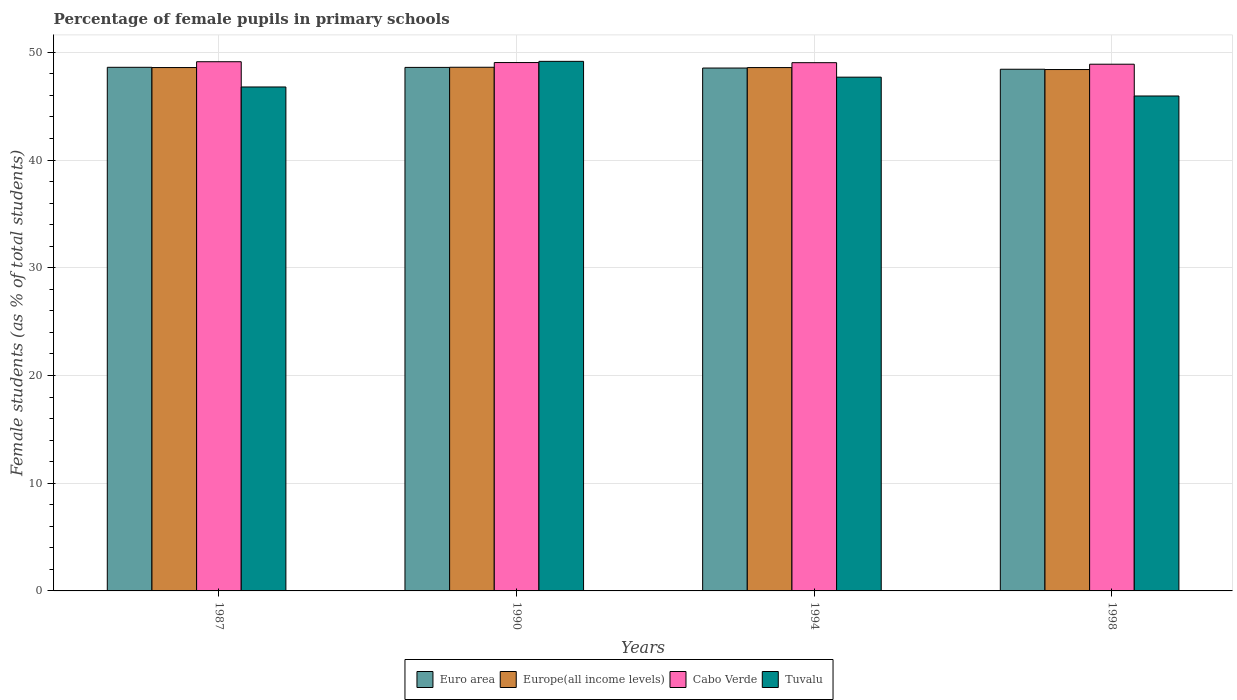How many different coloured bars are there?
Provide a short and direct response. 4. How many groups of bars are there?
Keep it short and to the point. 4. Are the number of bars on each tick of the X-axis equal?
Offer a very short reply. Yes. How many bars are there on the 1st tick from the left?
Offer a very short reply. 4. What is the label of the 2nd group of bars from the left?
Ensure brevity in your answer.  1990. In how many cases, is the number of bars for a given year not equal to the number of legend labels?
Offer a very short reply. 0. What is the percentage of female pupils in primary schools in Euro area in 1987?
Make the answer very short. 48.61. Across all years, what is the maximum percentage of female pupils in primary schools in Euro area?
Provide a short and direct response. 48.61. Across all years, what is the minimum percentage of female pupils in primary schools in Cabo Verde?
Give a very brief answer. 48.9. In which year was the percentage of female pupils in primary schools in Europe(all income levels) maximum?
Offer a terse response. 1990. In which year was the percentage of female pupils in primary schools in Tuvalu minimum?
Ensure brevity in your answer.  1998. What is the total percentage of female pupils in primary schools in Euro area in the graph?
Your answer should be very brief. 194.19. What is the difference between the percentage of female pupils in primary schools in Europe(all income levels) in 1990 and that in 1998?
Provide a short and direct response. 0.21. What is the difference between the percentage of female pupils in primary schools in Europe(all income levels) in 1987 and the percentage of female pupils in primary schools in Cabo Verde in 1994?
Your answer should be very brief. -0.45. What is the average percentage of female pupils in primary schools in Cabo Verde per year?
Offer a very short reply. 49.03. In the year 1987, what is the difference between the percentage of female pupils in primary schools in Europe(all income levels) and percentage of female pupils in primary schools in Tuvalu?
Offer a very short reply. 1.8. What is the ratio of the percentage of female pupils in primary schools in Cabo Verde in 1994 to that in 1998?
Keep it short and to the point. 1. Is the percentage of female pupils in primary schools in Euro area in 1994 less than that in 1998?
Provide a succinct answer. No. What is the difference between the highest and the second highest percentage of female pupils in primary schools in Europe(all income levels)?
Provide a succinct answer. 0.03. What is the difference between the highest and the lowest percentage of female pupils in primary schools in Tuvalu?
Make the answer very short. 3.22. In how many years, is the percentage of female pupils in primary schools in Euro area greater than the average percentage of female pupils in primary schools in Euro area taken over all years?
Offer a terse response. 2. Is the sum of the percentage of female pupils in primary schools in Cabo Verde in 1987 and 1998 greater than the maximum percentage of female pupils in primary schools in Euro area across all years?
Your answer should be compact. Yes. What does the 1st bar from the left in 1994 represents?
Provide a short and direct response. Euro area. How many bars are there?
Make the answer very short. 16. Are the values on the major ticks of Y-axis written in scientific E-notation?
Make the answer very short. No. Does the graph contain any zero values?
Give a very brief answer. No. Does the graph contain grids?
Make the answer very short. Yes. How many legend labels are there?
Offer a very short reply. 4. What is the title of the graph?
Ensure brevity in your answer.  Percentage of female pupils in primary schools. Does "Euro area" appear as one of the legend labels in the graph?
Provide a succinct answer. Yes. What is the label or title of the X-axis?
Your answer should be very brief. Years. What is the label or title of the Y-axis?
Offer a very short reply. Female students (as % of total students). What is the Female students (as % of total students) in Euro area in 1987?
Make the answer very short. 48.61. What is the Female students (as % of total students) in Europe(all income levels) in 1987?
Ensure brevity in your answer.  48.59. What is the Female students (as % of total students) in Cabo Verde in 1987?
Your answer should be compact. 49.13. What is the Female students (as % of total students) of Tuvalu in 1987?
Ensure brevity in your answer.  46.78. What is the Female students (as % of total students) in Euro area in 1990?
Offer a very short reply. 48.6. What is the Female students (as % of total students) in Europe(all income levels) in 1990?
Make the answer very short. 48.62. What is the Female students (as % of total students) of Cabo Verde in 1990?
Provide a succinct answer. 49.05. What is the Female students (as % of total students) in Tuvalu in 1990?
Give a very brief answer. 49.16. What is the Female students (as % of total students) of Euro area in 1994?
Provide a succinct answer. 48.54. What is the Female students (as % of total students) in Europe(all income levels) in 1994?
Your answer should be compact. 48.59. What is the Female students (as % of total students) of Cabo Verde in 1994?
Your answer should be compact. 49.04. What is the Female students (as % of total students) of Tuvalu in 1994?
Give a very brief answer. 47.7. What is the Female students (as % of total students) in Euro area in 1998?
Ensure brevity in your answer.  48.43. What is the Female students (as % of total students) in Europe(all income levels) in 1998?
Your response must be concise. 48.4. What is the Female students (as % of total students) in Cabo Verde in 1998?
Give a very brief answer. 48.9. What is the Female students (as % of total students) in Tuvalu in 1998?
Give a very brief answer. 45.95. Across all years, what is the maximum Female students (as % of total students) of Euro area?
Give a very brief answer. 48.61. Across all years, what is the maximum Female students (as % of total students) of Europe(all income levels)?
Offer a terse response. 48.62. Across all years, what is the maximum Female students (as % of total students) of Cabo Verde?
Offer a very short reply. 49.13. Across all years, what is the maximum Female students (as % of total students) of Tuvalu?
Offer a very short reply. 49.16. Across all years, what is the minimum Female students (as % of total students) of Euro area?
Keep it short and to the point. 48.43. Across all years, what is the minimum Female students (as % of total students) of Europe(all income levels)?
Keep it short and to the point. 48.4. Across all years, what is the minimum Female students (as % of total students) in Cabo Verde?
Make the answer very short. 48.9. Across all years, what is the minimum Female students (as % of total students) in Tuvalu?
Offer a very short reply. 45.95. What is the total Female students (as % of total students) in Euro area in the graph?
Your answer should be compact. 194.19. What is the total Female students (as % of total students) in Europe(all income levels) in the graph?
Give a very brief answer. 194.19. What is the total Female students (as % of total students) of Cabo Verde in the graph?
Offer a terse response. 196.12. What is the total Female students (as % of total students) in Tuvalu in the graph?
Offer a terse response. 189.59. What is the difference between the Female students (as % of total students) in Euro area in 1987 and that in 1990?
Your response must be concise. 0.01. What is the difference between the Female students (as % of total students) of Europe(all income levels) in 1987 and that in 1990?
Provide a short and direct response. -0.03. What is the difference between the Female students (as % of total students) of Cabo Verde in 1987 and that in 1990?
Provide a short and direct response. 0.08. What is the difference between the Female students (as % of total students) in Tuvalu in 1987 and that in 1990?
Offer a terse response. -2.38. What is the difference between the Female students (as % of total students) of Euro area in 1987 and that in 1994?
Your answer should be very brief. 0.07. What is the difference between the Female students (as % of total students) of Europe(all income levels) in 1987 and that in 1994?
Ensure brevity in your answer.  0. What is the difference between the Female students (as % of total students) of Cabo Verde in 1987 and that in 1994?
Your answer should be very brief. 0.09. What is the difference between the Female students (as % of total students) in Tuvalu in 1987 and that in 1994?
Your response must be concise. -0.91. What is the difference between the Female students (as % of total students) of Euro area in 1987 and that in 1998?
Your answer should be very brief. 0.18. What is the difference between the Female students (as % of total students) of Europe(all income levels) in 1987 and that in 1998?
Offer a very short reply. 0.18. What is the difference between the Female students (as % of total students) in Cabo Verde in 1987 and that in 1998?
Offer a terse response. 0.23. What is the difference between the Female students (as % of total students) of Tuvalu in 1987 and that in 1998?
Provide a short and direct response. 0.84. What is the difference between the Female students (as % of total students) of Euro area in 1990 and that in 1994?
Your response must be concise. 0.06. What is the difference between the Female students (as % of total students) of Europe(all income levels) in 1990 and that in 1994?
Offer a terse response. 0.03. What is the difference between the Female students (as % of total students) in Cabo Verde in 1990 and that in 1994?
Keep it short and to the point. 0.01. What is the difference between the Female students (as % of total students) in Tuvalu in 1990 and that in 1994?
Your answer should be compact. 1.47. What is the difference between the Female students (as % of total students) of Euro area in 1990 and that in 1998?
Make the answer very short. 0.17. What is the difference between the Female students (as % of total students) in Europe(all income levels) in 1990 and that in 1998?
Offer a terse response. 0.21. What is the difference between the Female students (as % of total students) in Cabo Verde in 1990 and that in 1998?
Ensure brevity in your answer.  0.15. What is the difference between the Female students (as % of total students) of Tuvalu in 1990 and that in 1998?
Provide a short and direct response. 3.22. What is the difference between the Female students (as % of total students) of Euro area in 1994 and that in 1998?
Make the answer very short. 0.11. What is the difference between the Female students (as % of total students) of Europe(all income levels) in 1994 and that in 1998?
Your answer should be compact. 0.18. What is the difference between the Female students (as % of total students) of Cabo Verde in 1994 and that in 1998?
Offer a very short reply. 0.14. What is the difference between the Female students (as % of total students) of Tuvalu in 1994 and that in 1998?
Keep it short and to the point. 1.75. What is the difference between the Female students (as % of total students) in Euro area in 1987 and the Female students (as % of total students) in Europe(all income levels) in 1990?
Offer a very short reply. -0.01. What is the difference between the Female students (as % of total students) of Euro area in 1987 and the Female students (as % of total students) of Cabo Verde in 1990?
Your response must be concise. -0.44. What is the difference between the Female students (as % of total students) in Euro area in 1987 and the Female students (as % of total students) in Tuvalu in 1990?
Provide a succinct answer. -0.55. What is the difference between the Female students (as % of total students) of Europe(all income levels) in 1987 and the Female students (as % of total students) of Cabo Verde in 1990?
Your response must be concise. -0.46. What is the difference between the Female students (as % of total students) of Europe(all income levels) in 1987 and the Female students (as % of total students) of Tuvalu in 1990?
Your answer should be compact. -0.58. What is the difference between the Female students (as % of total students) in Cabo Verde in 1987 and the Female students (as % of total students) in Tuvalu in 1990?
Offer a terse response. -0.04. What is the difference between the Female students (as % of total students) of Euro area in 1987 and the Female students (as % of total students) of Europe(all income levels) in 1994?
Keep it short and to the point. 0.02. What is the difference between the Female students (as % of total students) in Euro area in 1987 and the Female students (as % of total students) in Cabo Verde in 1994?
Give a very brief answer. -0.43. What is the difference between the Female students (as % of total students) in Euro area in 1987 and the Female students (as % of total students) in Tuvalu in 1994?
Your answer should be very brief. 0.91. What is the difference between the Female students (as % of total students) of Europe(all income levels) in 1987 and the Female students (as % of total students) of Cabo Verde in 1994?
Provide a short and direct response. -0.45. What is the difference between the Female students (as % of total students) in Europe(all income levels) in 1987 and the Female students (as % of total students) in Tuvalu in 1994?
Keep it short and to the point. 0.89. What is the difference between the Female students (as % of total students) in Cabo Verde in 1987 and the Female students (as % of total students) in Tuvalu in 1994?
Provide a short and direct response. 1.43. What is the difference between the Female students (as % of total students) in Euro area in 1987 and the Female students (as % of total students) in Europe(all income levels) in 1998?
Keep it short and to the point. 0.21. What is the difference between the Female students (as % of total students) in Euro area in 1987 and the Female students (as % of total students) in Cabo Verde in 1998?
Keep it short and to the point. -0.29. What is the difference between the Female students (as % of total students) of Euro area in 1987 and the Female students (as % of total students) of Tuvalu in 1998?
Your answer should be compact. 2.66. What is the difference between the Female students (as % of total students) in Europe(all income levels) in 1987 and the Female students (as % of total students) in Cabo Verde in 1998?
Keep it short and to the point. -0.31. What is the difference between the Female students (as % of total students) of Europe(all income levels) in 1987 and the Female students (as % of total students) of Tuvalu in 1998?
Offer a terse response. 2.64. What is the difference between the Female students (as % of total students) of Cabo Verde in 1987 and the Female students (as % of total students) of Tuvalu in 1998?
Provide a short and direct response. 3.18. What is the difference between the Female students (as % of total students) in Euro area in 1990 and the Female students (as % of total students) in Europe(all income levels) in 1994?
Your response must be concise. 0.02. What is the difference between the Female students (as % of total students) in Euro area in 1990 and the Female students (as % of total students) in Cabo Verde in 1994?
Your answer should be very brief. -0.44. What is the difference between the Female students (as % of total students) of Euro area in 1990 and the Female students (as % of total students) of Tuvalu in 1994?
Offer a terse response. 0.91. What is the difference between the Female students (as % of total students) of Europe(all income levels) in 1990 and the Female students (as % of total students) of Cabo Verde in 1994?
Give a very brief answer. -0.42. What is the difference between the Female students (as % of total students) of Europe(all income levels) in 1990 and the Female students (as % of total students) of Tuvalu in 1994?
Your answer should be compact. 0.92. What is the difference between the Female students (as % of total students) of Cabo Verde in 1990 and the Female students (as % of total students) of Tuvalu in 1994?
Your response must be concise. 1.36. What is the difference between the Female students (as % of total students) in Euro area in 1990 and the Female students (as % of total students) in Europe(all income levels) in 1998?
Provide a short and direct response. 0.2. What is the difference between the Female students (as % of total students) in Euro area in 1990 and the Female students (as % of total students) in Cabo Verde in 1998?
Provide a succinct answer. -0.3. What is the difference between the Female students (as % of total students) in Euro area in 1990 and the Female students (as % of total students) in Tuvalu in 1998?
Your answer should be compact. 2.65. What is the difference between the Female students (as % of total students) of Europe(all income levels) in 1990 and the Female students (as % of total students) of Cabo Verde in 1998?
Give a very brief answer. -0.28. What is the difference between the Female students (as % of total students) in Europe(all income levels) in 1990 and the Female students (as % of total students) in Tuvalu in 1998?
Make the answer very short. 2.67. What is the difference between the Female students (as % of total students) in Cabo Verde in 1990 and the Female students (as % of total students) in Tuvalu in 1998?
Offer a very short reply. 3.1. What is the difference between the Female students (as % of total students) in Euro area in 1994 and the Female students (as % of total students) in Europe(all income levels) in 1998?
Your response must be concise. 0.14. What is the difference between the Female students (as % of total students) of Euro area in 1994 and the Female students (as % of total students) of Cabo Verde in 1998?
Your response must be concise. -0.35. What is the difference between the Female students (as % of total students) in Euro area in 1994 and the Female students (as % of total students) in Tuvalu in 1998?
Keep it short and to the point. 2.6. What is the difference between the Female students (as % of total students) of Europe(all income levels) in 1994 and the Female students (as % of total students) of Cabo Verde in 1998?
Keep it short and to the point. -0.31. What is the difference between the Female students (as % of total students) of Europe(all income levels) in 1994 and the Female students (as % of total students) of Tuvalu in 1998?
Give a very brief answer. 2.64. What is the difference between the Female students (as % of total students) in Cabo Verde in 1994 and the Female students (as % of total students) in Tuvalu in 1998?
Provide a succinct answer. 3.09. What is the average Female students (as % of total students) of Euro area per year?
Keep it short and to the point. 48.55. What is the average Female students (as % of total students) of Europe(all income levels) per year?
Your response must be concise. 48.55. What is the average Female students (as % of total students) of Cabo Verde per year?
Your answer should be compact. 49.03. What is the average Female students (as % of total students) of Tuvalu per year?
Provide a succinct answer. 47.4. In the year 1987, what is the difference between the Female students (as % of total students) in Euro area and Female students (as % of total students) in Europe(all income levels)?
Offer a very short reply. 0.02. In the year 1987, what is the difference between the Female students (as % of total students) in Euro area and Female students (as % of total students) in Cabo Verde?
Provide a short and direct response. -0.52. In the year 1987, what is the difference between the Female students (as % of total students) of Euro area and Female students (as % of total students) of Tuvalu?
Offer a terse response. 1.83. In the year 1987, what is the difference between the Female students (as % of total students) in Europe(all income levels) and Female students (as % of total students) in Cabo Verde?
Keep it short and to the point. -0.54. In the year 1987, what is the difference between the Female students (as % of total students) in Europe(all income levels) and Female students (as % of total students) in Tuvalu?
Your answer should be very brief. 1.8. In the year 1987, what is the difference between the Female students (as % of total students) in Cabo Verde and Female students (as % of total students) in Tuvalu?
Make the answer very short. 2.34. In the year 1990, what is the difference between the Female students (as % of total students) in Euro area and Female students (as % of total students) in Europe(all income levels)?
Keep it short and to the point. -0.01. In the year 1990, what is the difference between the Female students (as % of total students) of Euro area and Female students (as % of total students) of Cabo Verde?
Make the answer very short. -0.45. In the year 1990, what is the difference between the Female students (as % of total students) of Euro area and Female students (as % of total students) of Tuvalu?
Make the answer very short. -0.56. In the year 1990, what is the difference between the Female students (as % of total students) of Europe(all income levels) and Female students (as % of total students) of Cabo Verde?
Give a very brief answer. -0.44. In the year 1990, what is the difference between the Female students (as % of total students) of Europe(all income levels) and Female students (as % of total students) of Tuvalu?
Offer a terse response. -0.55. In the year 1990, what is the difference between the Female students (as % of total students) in Cabo Verde and Female students (as % of total students) in Tuvalu?
Keep it short and to the point. -0.11. In the year 1994, what is the difference between the Female students (as % of total students) of Euro area and Female students (as % of total students) of Europe(all income levels)?
Provide a short and direct response. -0.04. In the year 1994, what is the difference between the Female students (as % of total students) of Euro area and Female students (as % of total students) of Cabo Verde?
Offer a terse response. -0.5. In the year 1994, what is the difference between the Female students (as % of total students) in Euro area and Female students (as % of total students) in Tuvalu?
Offer a very short reply. 0.85. In the year 1994, what is the difference between the Female students (as % of total students) of Europe(all income levels) and Female students (as % of total students) of Cabo Verde?
Your answer should be very brief. -0.45. In the year 1994, what is the difference between the Female students (as % of total students) in Europe(all income levels) and Female students (as % of total students) in Tuvalu?
Ensure brevity in your answer.  0.89. In the year 1994, what is the difference between the Female students (as % of total students) in Cabo Verde and Female students (as % of total students) in Tuvalu?
Provide a succinct answer. 1.34. In the year 1998, what is the difference between the Female students (as % of total students) in Euro area and Female students (as % of total students) in Europe(all income levels)?
Keep it short and to the point. 0.03. In the year 1998, what is the difference between the Female students (as % of total students) of Euro area and Female students (as % of total students) of Cabo Verde?
Ensure brevity in your answer.  -0.47. In the year 1998, what is the difference between the Female students (as % of total students) of Euro area and Female students (as % of total students) of Tuvalu?
Offer a very short reply. 2.48. In the year 1998, what is the difference between the Female students (as % of total students) of Europe(all income levels) and Female students (as % of total students) of Cabo Verde?
Keep it short and to the point. -0.49. In the year 1998, what is the difference between the Female students (as % of total students) in Europe(all income levels) and Female students (as % of total students) in Tuvalu?
Your answer should be compact. 2.46. In the year 1998, what is the difference between the Female students (as % of total students) of Cabo Verde and Female students (as % of total students) of Tuvalu?
Your response must be concise. 2.95. What is the ratio of the Female students (as % of total students) of Euro area in 1987 to that in 1990?
Your answer should be compact. 1. What is the ratio of the Female students (as % of total students) in Tuvalu in 1987 to that in 1990?
Offer a very short reply. 0.95. What is the ratio of the Female students (as % of total students) in Euro area in 1987 to that in 1994?
Ensure brevity in your answer.  1. What is the ratio of the Female students (as % of total students) of Europe(all income levels) in 1987 to that in 1994?
Keep it short and to the point. 1. What is the ratio of the Female students (as % of total students) of Cabo Verde in 1987 to that in 1994?
Provide a short and direct response. 1. What is the ratio of the Female students (as % of total students) in Tuvalu in 1987 to that in 1994?
Your response must be concise. 0.98. What is the ratio of the Female students (as % of total students) of Europe(all income levels) in 1987 to that in 1998?
Make the answer very short. 1. What is the ratio of the Female students (as % of total students) of Cabo Verde in 1987 to that in 1998?
Keep it short and to the point. 1. What is the ratio of the Female students (as % of total students) of Tuvalu in 1987 to that in 1998?
Your response must be concise. 1.02. What is the ratio of the Female students (as % of total students) in Europe(all income levels) in 1990 to that in 1994?
Your answer should be compact. 1. What is the ratio of the Female students (as % of total students) of Cabo Verde in 1990 to that in 1994?
Make the answer very short. 1. What is the ratio of the Female students (as % of total students) in Tuvalu in 1990 to that in 1994?
Make the answer very short. 1.03. What is the ratio of the Female students (as % of total students) of Cabo Verde in 1990 to that in 1998?
Give a very brief answer. 1. What is the ratio of the Female students (as % of total students) in Tuvalu in 1990 to that in 1998?
Keep it short and to the point. 1.07. What is the ratio of the Female students (as % of total students) of Euro area in 1994 to that in 1998?
Provide a short and direct response. 1. What is the ratio of the Female students (as % of total students) of Europe(all income levels) in 1994 to that in 1998?
Make the answer very short. 1. What is the ratio of the Female students (as % of total students) of Cabo Verde in 1994 to that in 1998?
Your response must be concise. 1. What is the ratio of the Female students (as % of total students) of Tuvalu in 1994 to that in 1998?
Your response must be concise. 1.04. What is the difference between the highest and the second highest Female students (as % of total students) in Euro area?
Offer a terse response. 0.01. What is the difference between the highest and the second highest Female students (as % of total students) of Europe(all income levels)?
Your answer should be very brief. 0.03. What is the difference between the highest and the second highest Female students (as % of total students) in Cabo Verde?
Provide a succinct answer. 0.08. What is the difference between the highest and the second highest Female students (as % of total students) of Tuvalu?
Offer a very short reply. 1.47. What is the difference between the highest and the lowest Female students (as % of total students) in Euro area?
Your answer should be compact. 0.18. What is the difference between the highest and the lowest Female students (as % of total students) in Europe(all income levels)?
Make the answer very short. 0.21. What is the difference between the highest and the lowest Female students (as % of total students) of Cabo Verde?
Give a very brief answer. 0.23. What is the difference between the highest and the lowest Female students (as % of total students) of Tuvalu?
Provide a short and direct response. 3.22. 